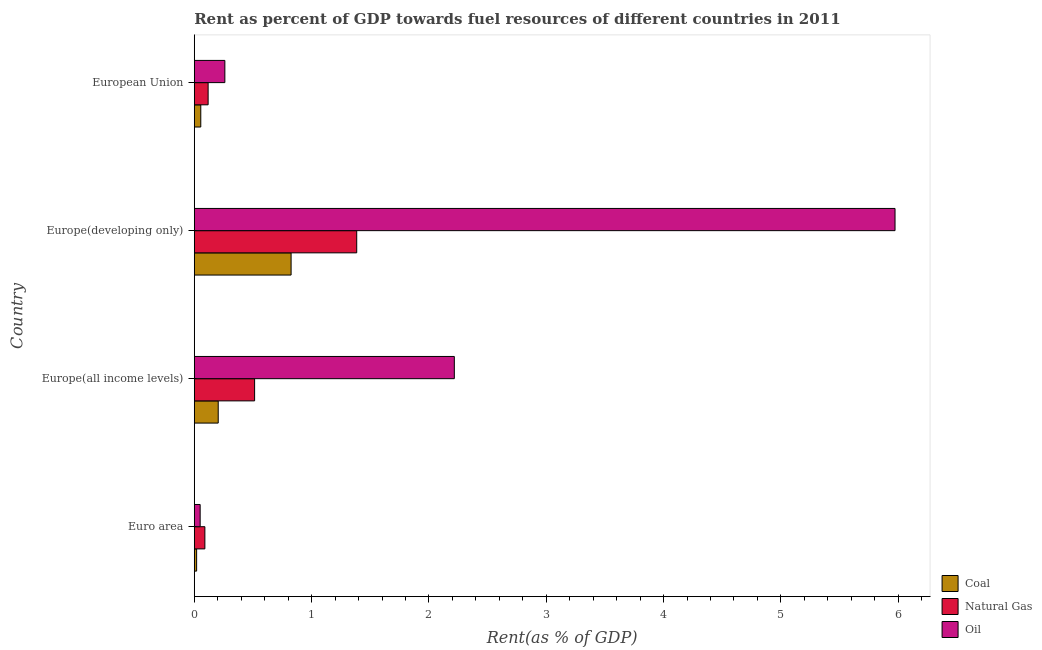How many different coloured bars are there?
Provide a succinct answer. 3. How many bars are there on the 3rd tick from the top?
Provide a short and direct response. 3. How many bars are there on the 1st tick from the bottom?
Your answer should be compact. 3. What is the label of the 3rd group of bars from the top?
Provide a succinct answer. Europe(all income levels). What is the rent towards oil in Europe(developing only)?
Provide a succinct answer. 5.97. Across all countries, what is the maximum rent towards natural gas?
Give a very brief answer. 1.38. Across all countries, what is the minimum rent towards natural gas?
Keep it short and to the point. 0.09. In which country was the rent towards coal maximum?
Ensure brevity in your answer.  Europe(developing only). What is the total rent towards natural gas in the graph?
Ensure brevity in your answer.  2.11. What is the difference between the rent towards coal in Europe(all income levels) and that in Europe(developing only)?
Your answer should be compact. -0.62. What is the difference between the rent towards coal in Europe(all income levels) and the rent towards oil in European Union?
Your response must be concise. -0.06. What is the average rent towards coal per country?
Offer a terse response. 0.28. What is the difference between the rent towards oil and rent towards coal in Euro area?
Offer a very short reply. 0.03. What is the ratio of the rent towards coal in Europe(all income levels) to that in Europe(developing only)?
Your response must be concise. 0.25. What is the difference between the highest and the second highest rent towards natural gas?
Provide a succinct answer. 0.87. What is the difference between the highest and the lowest rent towards coal?
Offer a very short reply. 0.81. In how many countries, is the rent towards natural gas greater than the average rent towards natural gas taken over all countries?
Offer a very short reply. 1. Is the sum of the rent towards natural gas in Euro area and European Union greater than the maximum rent towards oil across all countries?
Provide a short and direct response. No. What does the 2nd bar from the top in Europe(all income levels) represents?
Your answer should be very brief. Natural Gas. What does the 3rd bar from the bottom in Europe(developing only) represents?
Provide a succinct answer. Oil. Does the graph contain grids?
Your answer should be very brief. No. How many legend labels are there?
Offer a very short reply. 3. How are the legend labels stacked?
Offer a very short reply. Vertical. What is the title of the graph?
Offer a very short reply. Rent as percent of GDP towards fuel resources of different countries in 2011. What is the label or title of the X-axis?
Your response must be concise. Rent(as % of GDP). What is the label or title of the Y-axis?
Offer a terse response. Country. What is the Rent(as % of GDP) in Coal in Euro area?
Offer a terse response. 0.02. What is the Rent(as % of GDP) of Natural Gas in Euro area?
Make the answer very short. 0.09. What is the Rent(as % of GDP) in Oil in Euro area?
Offer a very short reply. 0.05. What is the Rent(as % of GDP) in Coal in Europe(all income levels)?
Keep it short and to the point. 0.2. What is the Rent(as % of GDP) in Natural Gas in Europe(all income levels)?
Make the answer very short. 0.51. What is the Rent(as % of GDP) in Oil in Europe(all income levels)?
Ensure brevity in your answer.  2.22. What is the Rent(as % of GDP) in Coal in Europe(developing only)?
Your answer should be compact. 0.83. What is the Rent(as % of GDP) in Natural Gas in Europe(developing only)?
Offer a very short reply. 1.38. What is the Rent(as % of GDP) in Oil in Europe(developing only)?
Provide a short and direct response. 5.97. What is the Rent(as % of GDP) of Coal in European Union?
Your answer should be compact. 0.06. What is the Rent(as % of GDP) in Natural Gas in European Union?
Give a very brief answer. 0.12. What is the Rent(as % of GDP) of Oil in European Union?
Give a very brief answer. 0.26. Across all countries, what is the maximum Rent(as % of GDP) of Coal?
Provide a succinct answer. 0.83. Across all countries, what is the maximum Rent(as % of GDP) in Natural Gas?
Provide a succinct answer. 1.38. Across all countries, what is the maximum Rent(as % of GDP) in Oil?
Your answer should be compact. 5.97. Across all countries, what is the minimum Rent(as % of GDP) in Coal?
Make the answer very short. 0.02. Across all countries, what is the minimum Rent(as % of GDP) in Natural Gas?
Ensure brevity in your answer.  0.09. Across all countries, what is the minimum Rent(as % of GDP) of Oil?
Your answer should be very brief. 0.05. What is the total Rent(as % of GDP) of Coal in the graph?
Ensure brevity in your answer.  1.1. What is the total Rent(as % of GDP) of Natural Gas in the graph?
Your answer should be very brief. 2.11. What is the total Rent(as % of GDP) in Oil in the graph?
Offer a terse response. 8.5. What is the difference between the Rent(as % of GDP) in Coal in Euro area and that in Europe(all income levels)?
Your answer should be very brief. -0.18. What is the difference between the Rent(as % of GDP) of Natural Gas in Euro area and that in Europe(all income levels)?
Make the answer very short. -0.42. What is the difference between the Rent(as % of GDP) of Oil in Euro area and that in Europe(all income levels)?
Your answer should be compact. -2.17. What is the difference between the Rent(as % of GDP) in Coal in Euro area and that in Europe(developing only)?
Your answer should be compact. -0.81. What is the difference between the Rent(as % of GDP) of Natural Gas in Euro area and that in Europe(developing only)?
Keep it short and to the point. -1.29. What is the difference between the Rent(as % of GDP) of Oil in Euro area and that in Europe(developing only)?
Give a very brief answer. -5.92. What is the difference between the Rent(as % of GDP) in Coal in Euro area and that in European Union?
Your answer should be very brief. -0.04. What is the difference between the Rent(as % of GDP) of Natural Gas in Euro area and that in European Union?
Keep it short and to the point. -0.03. What is the difference between the Rent(as % of GDP) of Oil in Euro area and that in European Union?
Give a very brief answer. -0.21. What is the difference between the Rent(as % of GDP) of Coal in Europe(all income levels) and that in Europe(developing only)?
Your answer should be very brief. -0.62. What is the difference between the Rent(as % of GDP) of Natural Gas in Europe(all income levels) and that in Europe(developing only)?
Provide a succinct answer. -0.87. What is the difference between the Rent(as % of GDP) of Oil in Europe(all income levels) and that in Europe(developing only)?
Provide a short and direct response. -3.76. What is the difference between the Rent(as % of GDP) in Coal in Europe(all income levels) and that in European Union?
Your response must be concise. 0.15. What is the difference between the Rent(as % of GDP) of Natural Gas in Europe(all income levels) and that in European Union?
Keep it short and to the point. 0.4. What is the difference between the Rent(as % of GDP) in Oil in Europe(all income levels) and that in European Union?
Offer a very short reply. 1.96. What is the difference between the Rent(as % of GDP) in Coal in Europe(developing only) and that in European Union?
Give a very brief answer. 0.77. What is the difference between the Rent(as % of GDP) of Natural Gas in Europe(developing only) and that in European Union?
Your answer should be very brief. 1.27. What is the difference between the Rent(as % of GDP) in Oil in Europe(developing only) and that in European Union?
Give a very brief answer. 5.71. What is the difference between the Rent(as % of GDP) in Coal in Euro area and the Rent(as % of GDP) in Natural Gas in Europe(all income levels)?
Ensure brevity in your answer.  -0.49. What is the difference between the Rent(as % of GDP) in Coal in Euro area and the Rent(as % of GDP) in Oil in Europe(all income levels)?
Give a very brief answer. -2.2. What is the difference between the Rent(as % of GDP) of Natural Gas in Euro area and the Rent(as % of GDP) of Oil in Europe(all income levels)?
Keep it short and to the point. -2.13. What is the difference between the Rent(as % of GDP) in Coal in Euro area and the Rent(as % of GDP) in Natural Gas in Europe(developing only)?
Ensure brevity in your answer.  -1.36. What is the difference between the Rent(as % of GDP) in Coal in Euro area and the Rent(as % of GDP) in Oil in Europe(developing only)?
Keep it short and to the point. -5.95. What is the difference between the Rent(as % of GDP) in Natural Gas in Euro area and the Rent(as % of GDP) in Oil in Europe(developing only)?
Offer a terse response. -5.88. What is the difference between the Rent(as % of GDP) of Coal in Euro area and the Rent(as % of GDP) of Natural Gas in European Union?
Your answer should be very brief. -0.1. What is the difference between the Rent(as % of GDP) in Coal in Euro area and the Rent(as % of GDP) in Oil in European Union?
Your answer should be very brief. -0.24. What is the difference between the Rent(as % of GDP) in Natural Gas in Euro area and the Rent(as % of GDP) in Oil in European Union?
Provide a succinct answer. -0.17. What is the difference between the Rent(as % of GDP) of Coal in Europe(all income levels) and the Rent(as % of GDP) of Natural Gas in Europe(developing only)?
Provide a short and direct response. -1.18. What is the difference between the Rent(as % of GDP) of Coal in Europe(all income levels) and the Rent(as % of GDP) of Oil in Europe(developing only)?
Ensure brevity in your answer.  -5.77. What is the difference between the Rent(as % of GDP) in Natural Gas in Europe(all income levels) and the Rent(as % of GDP) in Oil in Europe(developing only)?
Provide a short and direct response. -5.46. What is the difference between the Rent(as % of GDP) of Coal in Europe(all income levels) and the Rent(as % of GDP) of Natural Gas in European Union?
Give a very brief answer. 0.09. What is the difference between the Rent(as % of GDP) of Coal in Europe(all income levels) and the Rent(as % of GDP) of Oil in European Union?
Provide a succinct answer. -0.06. What is the difference between the Rent(as % of GDP) of Natural Gas in Europe(all income levels) and the Rent(as % of GDP) of Oil in European Union?
Offer a very short reply. 0.25. What is the difference between the Rent(as % of GDP) of Coal in Europe(developing only) and the Rent(as % of GDP) of Natural Gas in European Union?
Ensure brevity in your answer.  0.71. What is the difference between the Rent(as % of GDP) of Coal in Europe(developing only) and the Rent(as % of GDP) of Oil in European Union?
Ensure brevity in your answer.  0.56. What is the difference between the Rent(as % of GDP) of Natural Gas in Europe(developing only) and the Rent(as % of GDP) of Oil in European Union?
Give a very brief answer. 1.12. What is the average Rent(as % of GDP) of Coal per country?
Offer a very short reply. 0.28. What is the average Rent(as % of GDP) in Natural Gas per country?
Provide a short and direct response. 0.53. What is the average Rent(as % of GDP) in Oil per country?
Keep it short and to the point. 2.13. What is the difference between the Rent(as % of GDP) in Coal and Rent(as % of GDP) in Natural Gas in Euro area?
Give a very brief answer. -0.07. What is the difference between the Rent(as % of GDP) of Coal and Rent(as % of GDP) of Oil in Euro area?
Offer a terse response. -0.03. What is the difference between the Rent(as % of GDP) in Natural Gas and Rent(as % of GDP) in Oil in Euro area?
Provide a succinct answer. 0.04. What is the difference between the Rent(as % of GDP) in Coal and Rent(as % of GDP) in Natural Gas in Europe(all income levels)?
Provide a short and direct response. -0.31. What is the difference between the Rent(as % of GDP) in Coal and Rent(as % of GDP) in Oil in Europe(all income levels)?
Keep it short and to the point. -2.01. What is the difference between the Rent(as % of GDP) of Natural Gas and Rent(as % of GDP) of Oil in Europe(all income levels)?
Provide a succinct answer. -1.7. What is the difference between the Rent(as % of GDP) of Coal and Rent(as % of GDP) of Natural Gas in Europe(developing only)?
Give a very brief answer. -0.56. What is the difference between the Rent(as % of GDP) of Coal and Rent(as % of GDP) of Oil in Europe(developing only)?
Your answer should be compact. -5.15. What is the difference between the Rent(as % of GDP) in Natural Gas and Rent(as % of GDP) in Oil in Europe(developing only)?
Offer a very short reply. -4.59. What is the difference between the Rent(as % of GDP) of Coal and Rent(as % of GDP) of Natural Gas in European Union?
Offer a terse response. -0.06. What is the difference between the Rent(as % of GDP) in Coal and Rent(as % of GDP) in Oil in European Union?
Keep it short and to the point. -0.21. What is the difference between the Rent(as % of GDP) in Natural Gas and Rent(as % of GDP) in Oil in European Union?
Offer a terse response. -0.14. What is the ratio of the Rent(as % of GDP) of Coal in Euro area to that in Europe(all income levels)?
Offer a terse response. 0.1. What is the ratio of the Rent(as % of GDP) in Natural Gas in Euro area to that in Europe(all income levels)?
Provide a short and direct response. 0.18. What is the ratio of the Rent(as % of GDP) in Oil in Euro area to that in Europe(all income levels)?
Ensure brevity in your answer.  0.02. What is the ratio of the Rent(as % of GDP) of Coal in Euro area to that in Europe(developing only)?
Give a very brief answer. 0.02. What is the ratio of the Rent(as % of GDP) in Natural Gas in Euro area to that in Europe(developing only)?
Your answer should be very brief. 0.07. What is the ratio of the Rent(as % of GDP) of Oil in Euro area to that in Europe(developing only)?
Keep it short and to the point. 0.01. What is the ratio of the Rent(as % of GDP) of Coal in Euro area to that in European Union?
Give a very brief answer. 0.36. What is the ratio of the Rent(as % of GDP) of Natural Gas in Euro area to that in European Union?
Your answer should be compact. 0.77. What is the ratio of the Rent(as % of GDP) of Oil in Euro area to that in European Union?
Keep it short and to the point. 0.19. What is the ratio of the Rent(as % of GDP) of Coal in Europe(all income levels) to that in Europe(developing only)?
Provide a succinct answer. 0.25. What is the ratio of the Rent(as % of GDP) in Natural Gas in Europe(all income levels) to that in Europe(developing only)?
Your response must be concise. 0.37. What is the ratio of the Rent(as % of GDP) in Oil in Europe(all income levels) to that in Europe(developing only)?
Provide a succinct answer. 0.37. What is the ratio of the Rent(as % of GDP) in Coal in Europe(all income levels) to that in European Union?
Make the answer very short. 3.67. What is the ratio of the Rent(as % of GDP) in Natural Gas in Europe(all income levels) to that in European Union?
Offer a terse response. 4.35. What is the ratio of the Rent(as % of GDP) of Oil in Europe(all income levels) to that in European Union?
Ensure brevity in your answer.  8.5. What is the ratio of the Rent(as % of GDP) in Coal in Europe(developing only) to that in European Union?
Offer a very short reply. 14.85. What is the ratio of the Rent(as % of GDP) of Natural Gas in Europe(developing only) to that in European Union?
Offer a terse response. 11.72. What is the ratio of the Rent(as % of GDP) in Oil in Europe(developing only) to that in European Union?
Your answer should be very brief. 22.9. What is the difference between the highest and the second highest Rent(as % of GDP) of Coal?
Offer a very short reply. 0.62. What is the difference between the highest and the second highest Rent(as % of GDP) of Natural Gas?
Give a very brief answer. 0.87. What is the difference between the highest and the second highest Rent(as % of GDP) in Oil?
Provide a short and direct response. 3.76. What is the difference between the highest and the lowest Rent(as % of GDP) of Coal?
Keep it short and to the point. 0.81. What is the difference between the highest and the lowest Rent(as % of GDP) of Natural Gas?
Offer a very short reply. 1.29. What is the difference between the highest and the lowest Rent(as % of GDP) of Oil?
Your answer should be very brief. 5.92. 